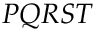<formula> <loc_0><loc_0><loc_500><loc_500>P Q R S T</formula> 